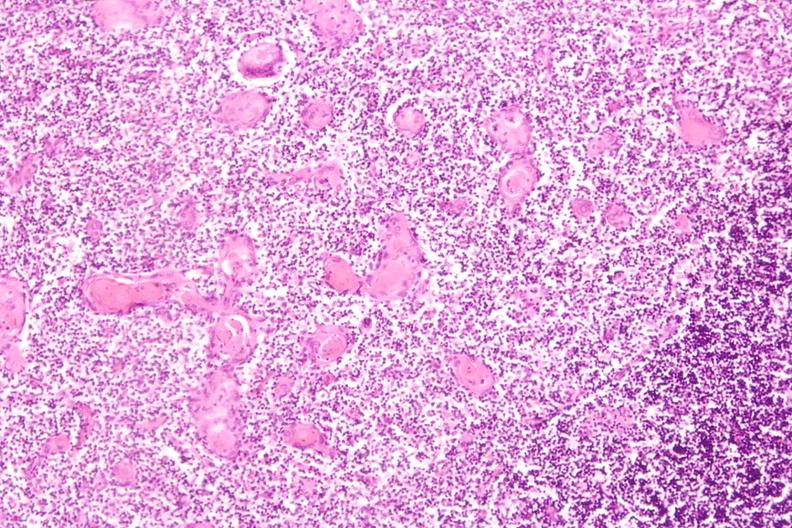what induce involution in baby with hyaline membrane disease?
Answer the question using a single word or phrase. Thymus, stress 